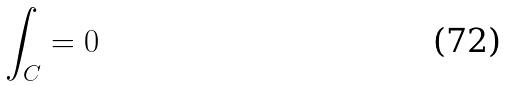<formula> <loc_0><loc_0><loc_500><loc_500>\int _ { C } = 0</formula> 